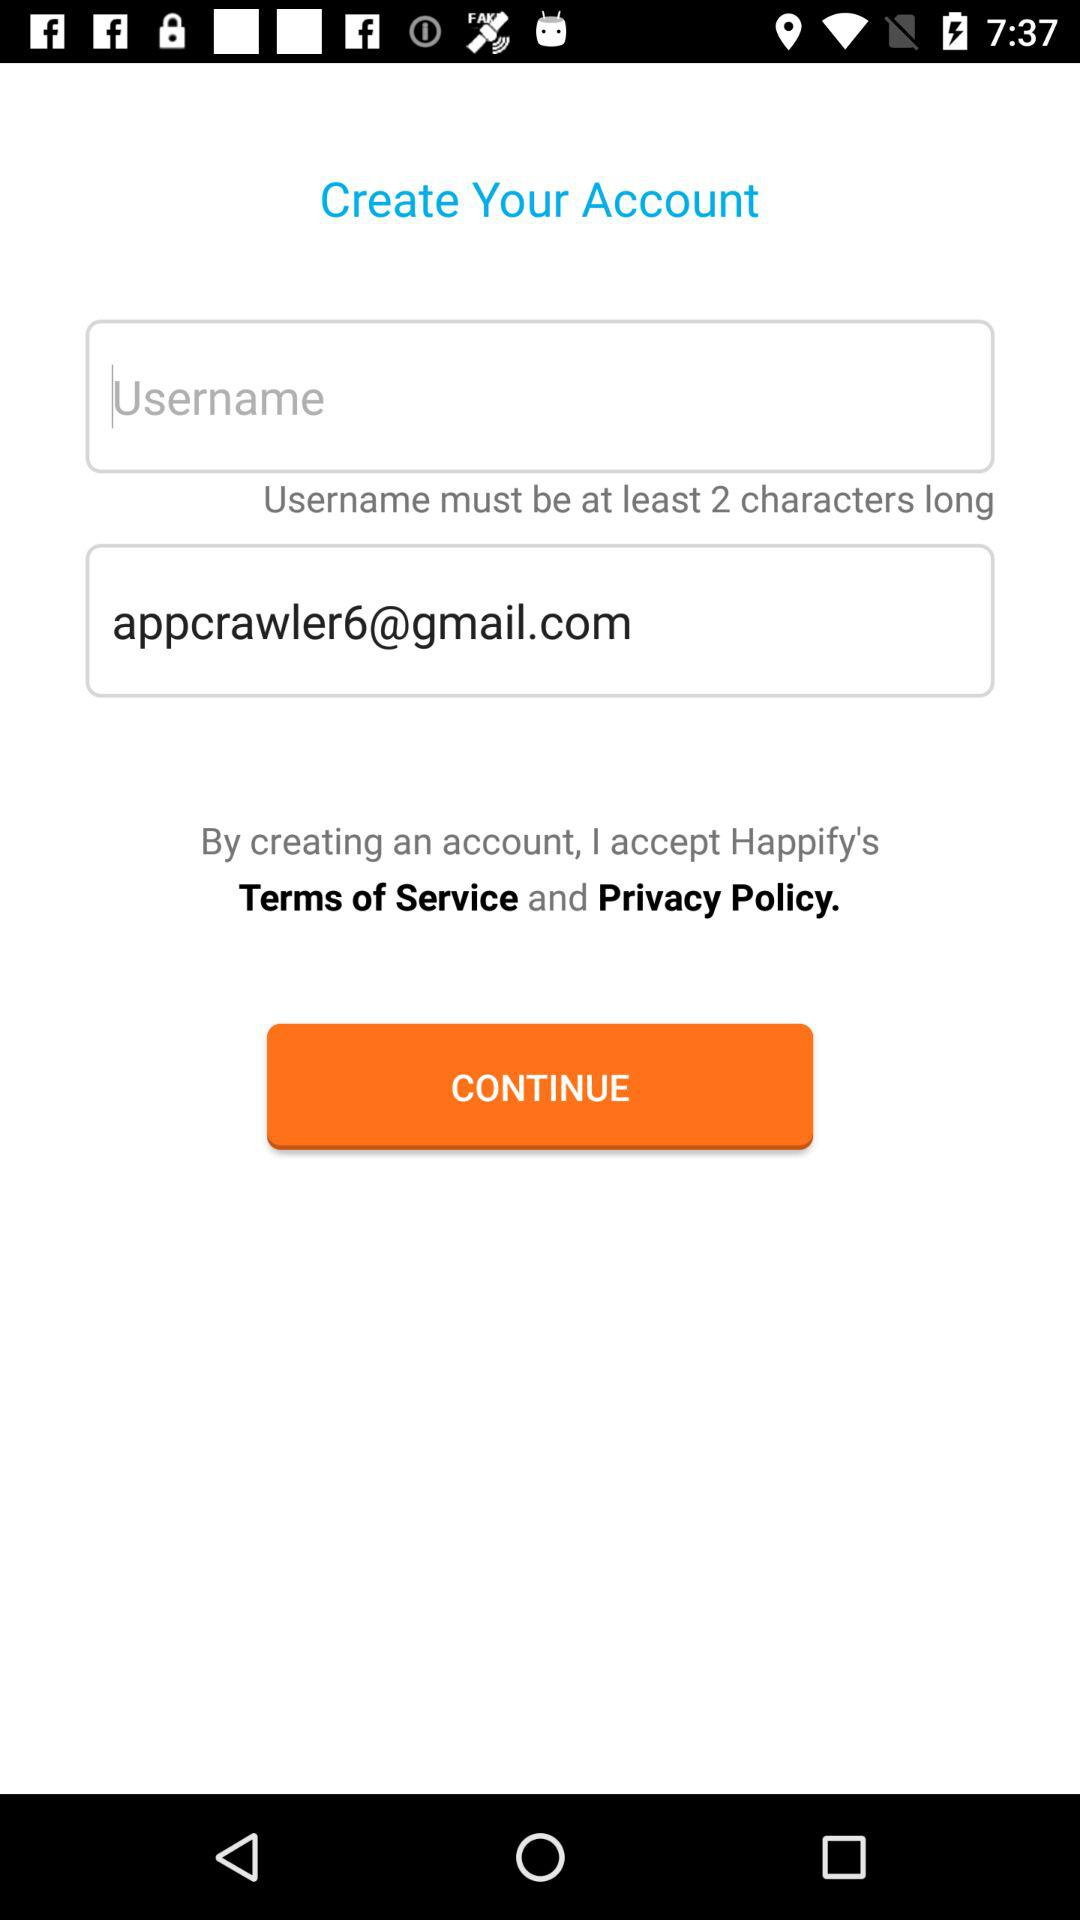What is the name of the user?
When the provided information is insufficient, respond with <no answer>. <no answer> 